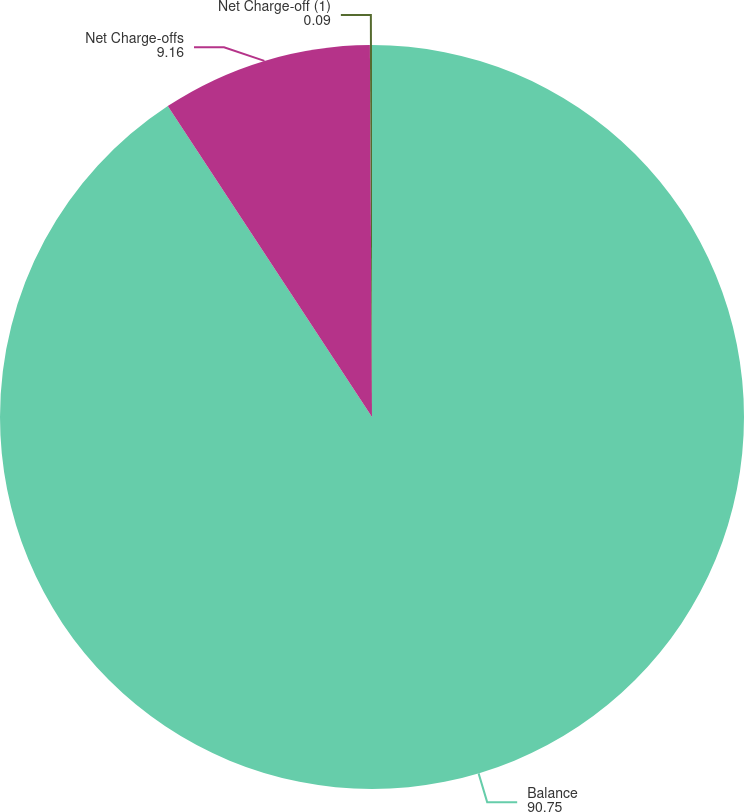Convert chart to OTSL. <chart><loc_0><loc_0><loc_500><loc_500><pie_chart><fcel>Balance<fcel>Net Charge-offs<fcel>Net Charge-off (1)<nl><fcel>90.75%<fcel>9.16%<fcel>0.09%<nl></chart> 